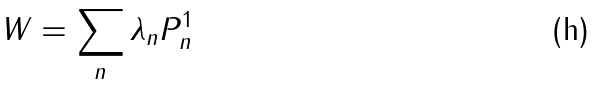Convert formula to latex. <formula><loc_0><loc_0><loc_500><loc_500>W = \sum _ { n } { \lambda } _ { n } P _ { n } ^ { 1 }</formula> 